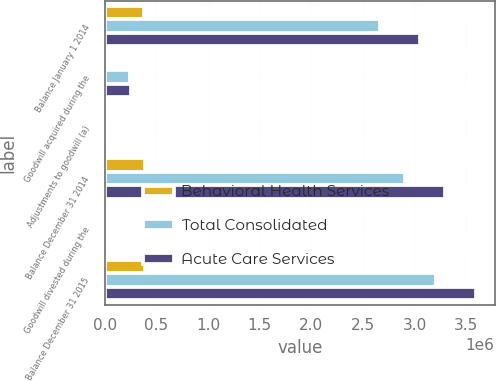Convert chart. <chart><loc_0><loc_0><loc_500><loc_500><stacked_bar_chart><ecel><fcel>Balance January 1 2014<fcel>Goodwill acquired during the<fcel>Adjustments to goodwill (a)<fcel>Balance December 31 2014<fcel>Goodwill divested during the<fcel>Balance December 31 2015<nl><fcel>Behavioral Health Services<fcel>383011<fcel>4088<fcel>0<fcel>387099<fcel>0<fcel>389507<nl><fcel>Total Consolidated<fcel>2.666e+06<fcel>246124<fcel>8015<fcel>2.90411e+06<fcel>1497<fcel>3.20661e+06<nl><fcel>Acute Care Services<fcel>3.04902e+06<fcel>250212<fcel>8015<fcel>3.29121e+06<fcel>1497<fcel>3.59611e+06<nl></chart> 